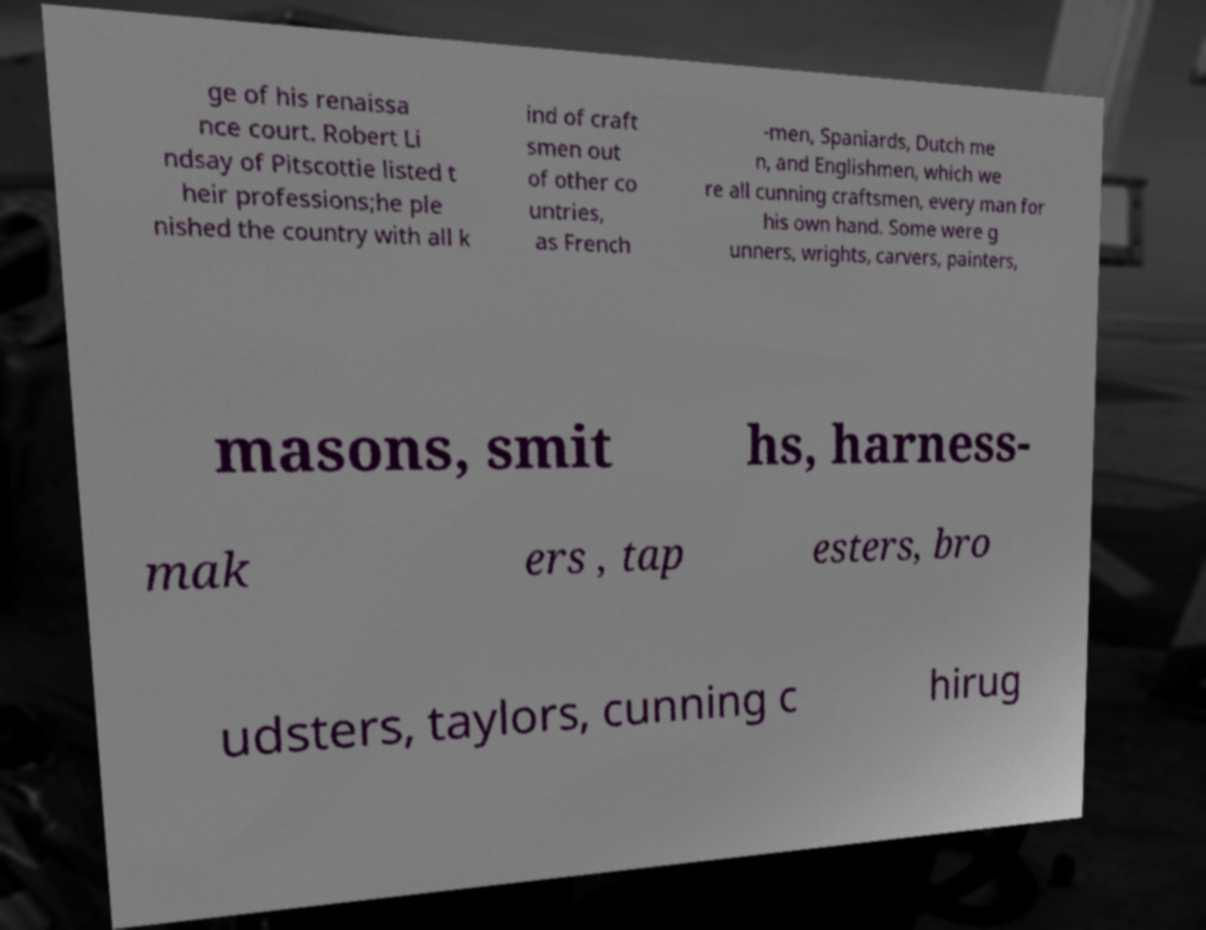Please read and relay the text visible in this image. What does it say? ge of his renaissa nce court. Robert Li ndsay of Pitscottie listed t heir professions;he ple nished the country with all k ind of craft smen out of other co untries, as French -men, Spaniards, Dutch me n, and Englishmen, which we re all cunning craftsmen, every man for his own hand. Some were g unners, wrights, carvers, painters, masons, smit hs, harness- mak ers , tap esters, bro udsters, taylors, cunning c hirug 